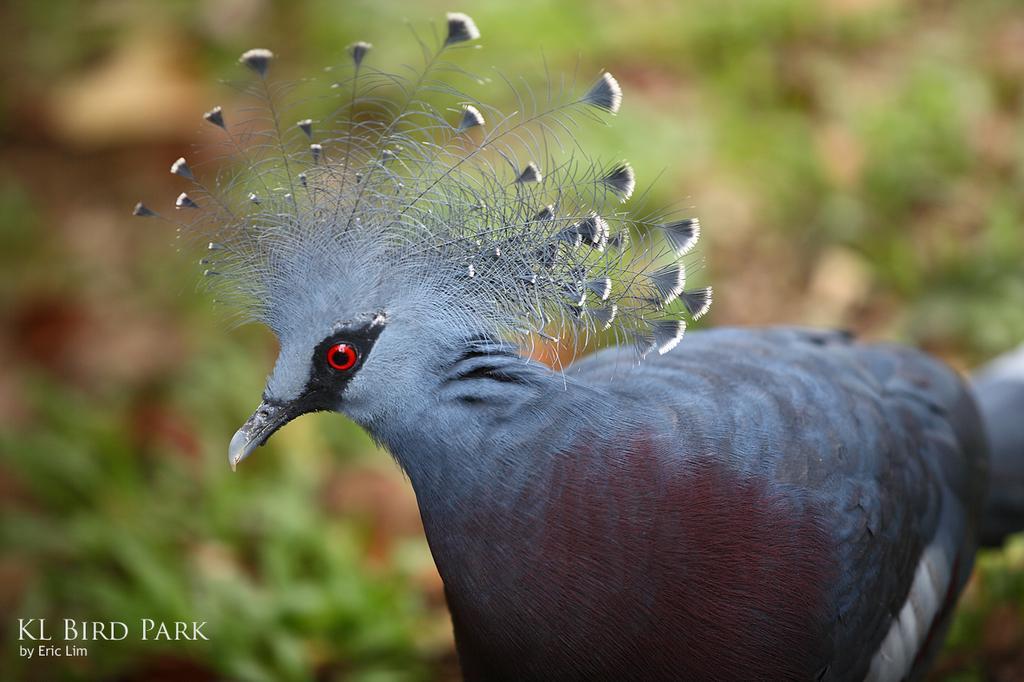How would you summarize this image in a sentence or two? In this image there is a beautiful bird, in the background it is blurred. 